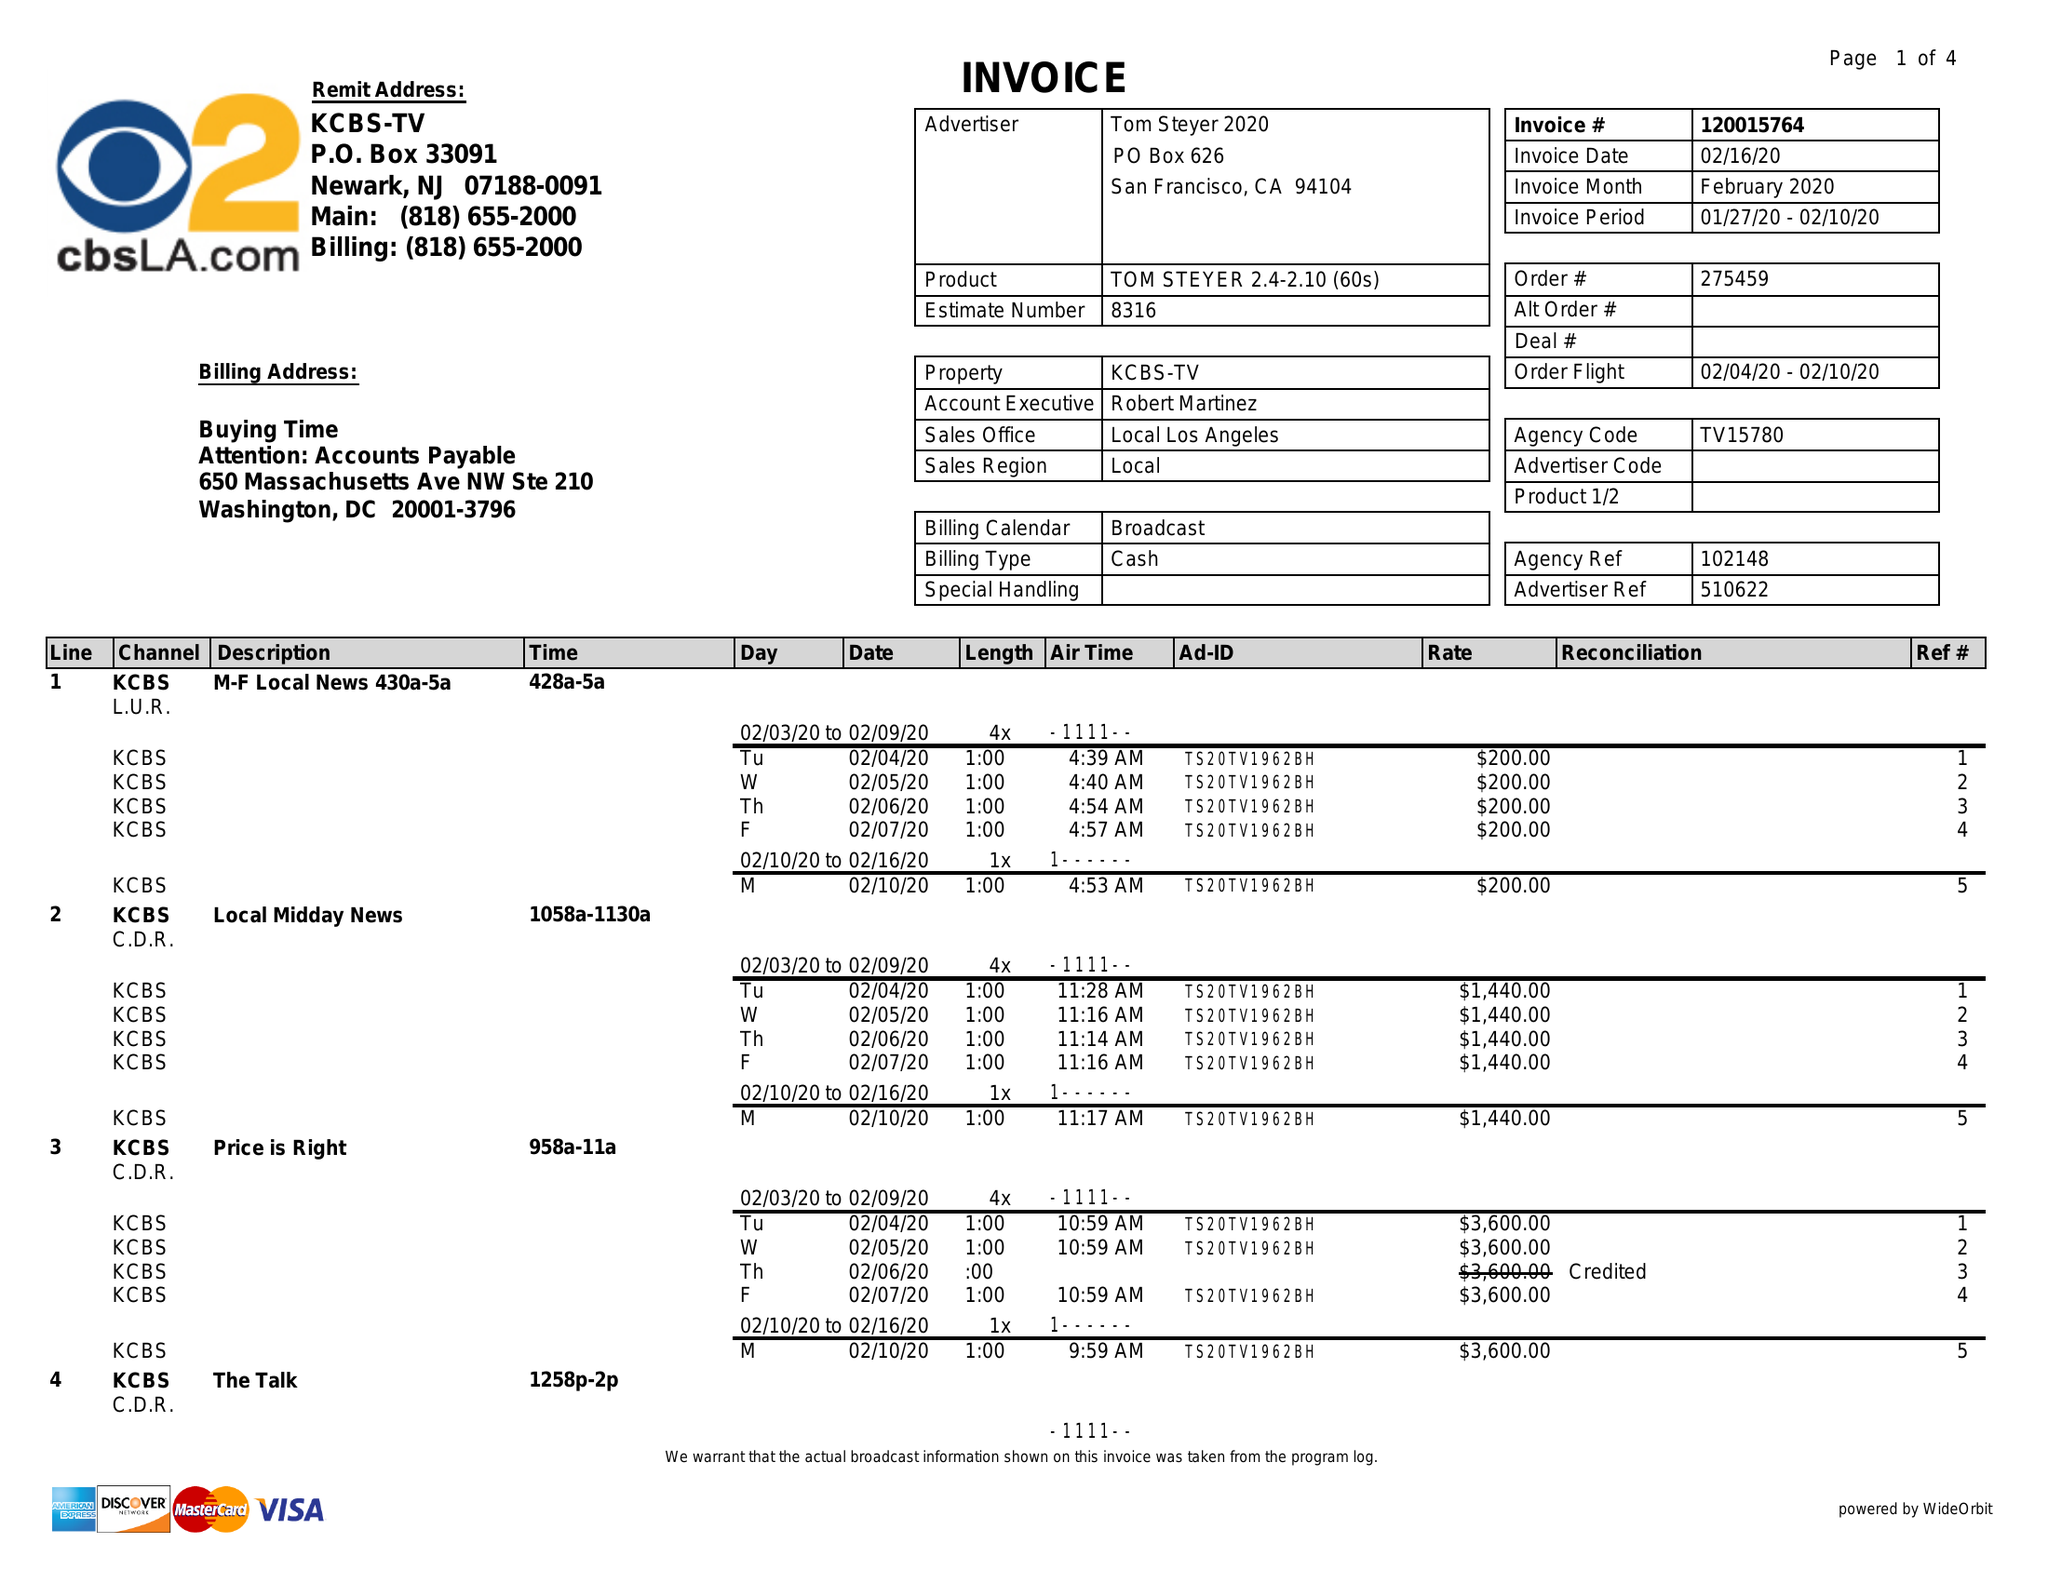What is the value for the flight_from?
Answer the question using a single word or phrase. 02/04/20 